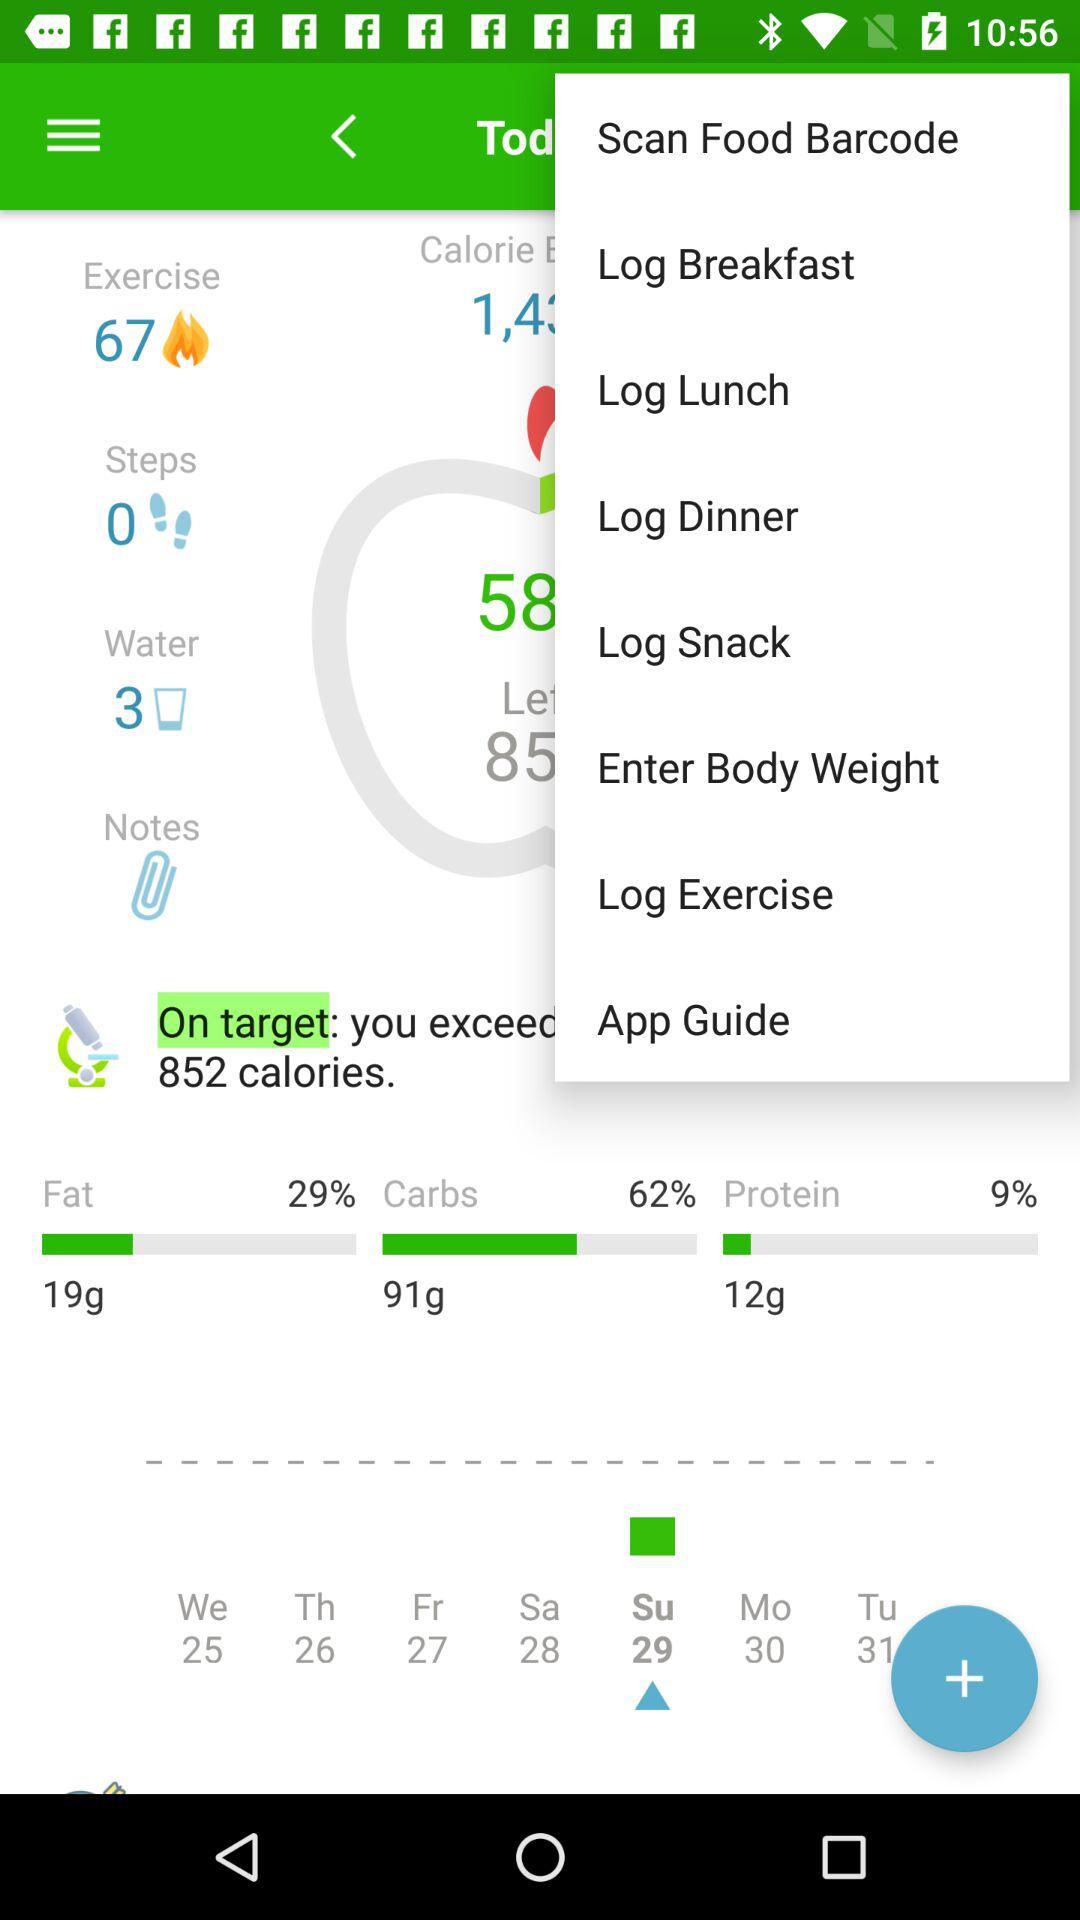How much is the intake of water? The intake of water is 3 glasses. 